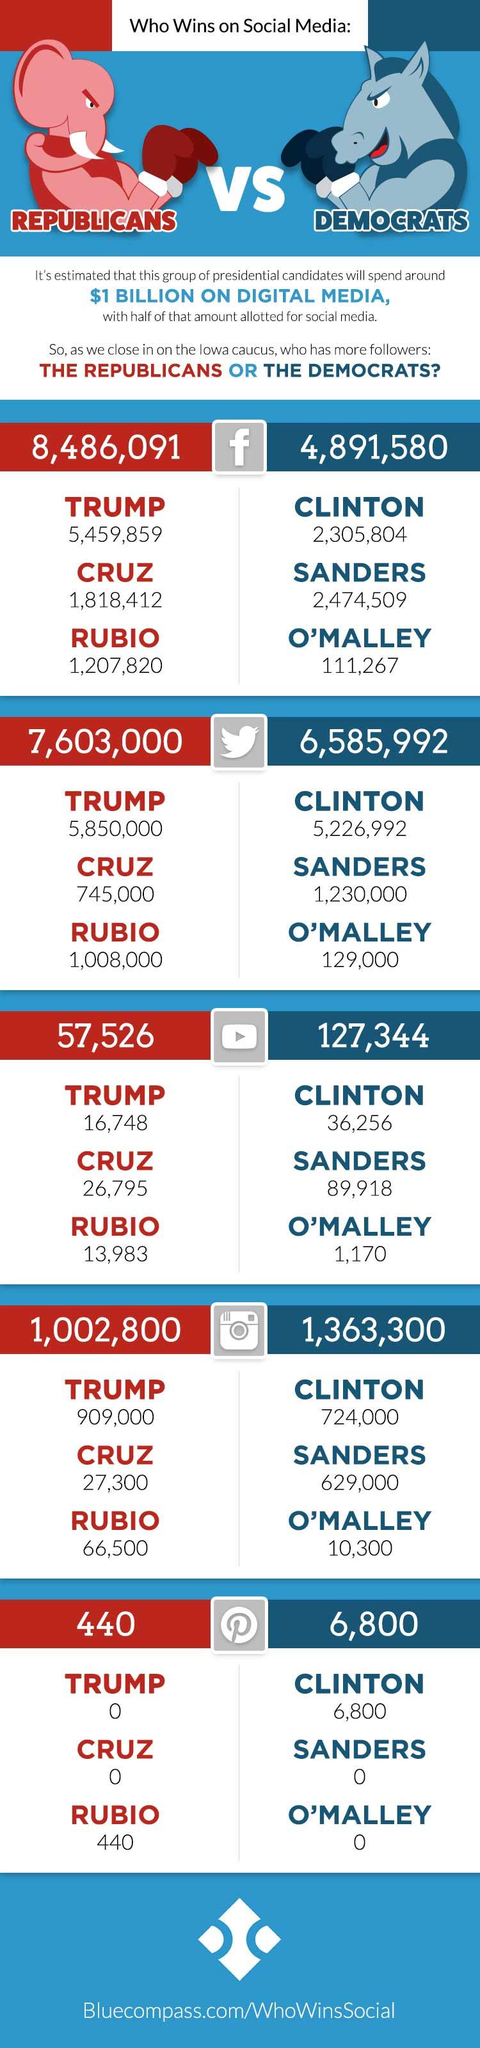Indicate a few pertinent items in this graphic. According to the information available, it is known that Trump had more followers on Instagram than Clinton during the 2016 presidential election. The Democrats had the highest number of followers on Twitter among social media platforms. Barack Obama did not have any followers on Pinterest. During the 2016 Republican primary, three candidates emerged as contenders for the party's nomination: Donald Trump, Ted Cruz, and Marco Rubio. The Republicans had the highest number of followers on Facebook, according to data from the platforms themselves. 